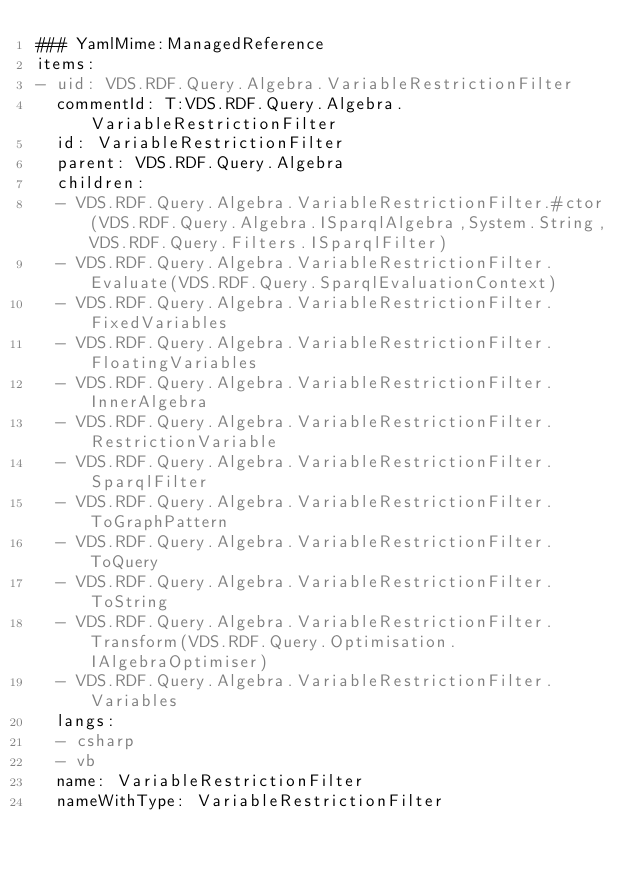<code> <loc_0><loc_0><loc_500><loc_500><_YAML_>### YamlMime:ManagedReference
items:
- uid: VDS.RDF.Query.Algebra.VariableRestrictionFilter
  commentId: T:VDS.RDF.Query.Algebra.VariableRestrictionFilter
  id: VariableRestrictionFilter
  parent: VDS.RDF.Query.Algebra
  children:
  - VDS.RDF.Query.Algebra.VariableRestrictionFilter.#ctor(VDS.RDF.Query.Algebra.ISparqlAlgebra,System.String,VDS.RDF.Query.Filters.ISparqlFilter)
  - VDS.RDF.Query.Algebra.VariableRestrictionFilter.Evaluate(VDS.RDF.Query.SparqlEvaluationContext)
  - VDS.RDF.Query.Algebra.VariableRestrictionFilter.FixedVariables
  - VDS.RDF.Query.Algebra.VariableRestrictionFilter.FloatingVariables
  - VDS.RDF.Query.Algebra.VariableRestrictionFilter.InnerAlgebra
  - VDS.RDF.Query.Algebra.VariableRestrictionFilter.RestrictionVariable
  - VDS.RDF.Query.Algebra.VariableRestrictionFilter.SparqlFilter
  - VDS.RDF.Query.Algebra.VariableRestrictionFilter.ToGraphPattern
  - VDS.RDF.Query.Algebra.VariableRestrictionFilter.ToQuery
  - VDS.RDF.Query.Algebra.VariableRestrictionFilter.ToString
  - VDS.RDF.Query.Algebra.VariableRestrictionFilter.Transform(VDS.RDF.Query.Optimisation.IAlgebraOptimiser)
  - VDS.RDF.Query.Algebra.VariableRestrictionFilter.Variables
  langs:
  - csharp
  - vb
  name: VariableRestrictionFilter
  nameWithType: VariableRestrictionFilter</code> 